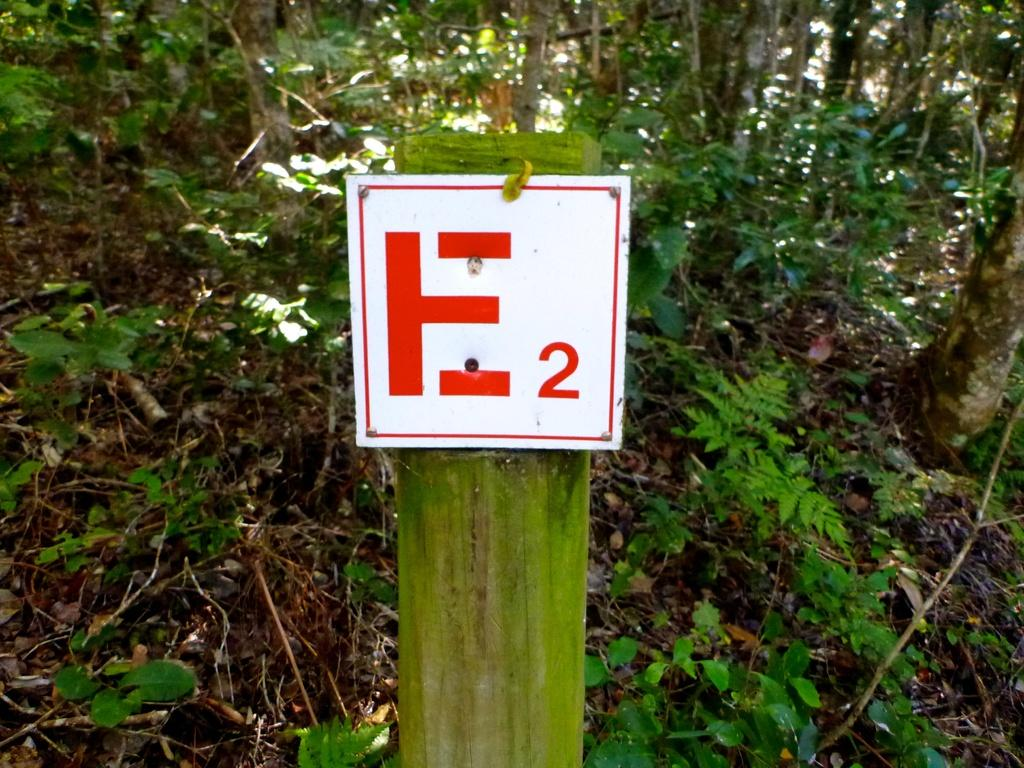What is located in the center of the image? There is a board in the center of the image. What can be seen in the background of the image? There are trees and plants in the background of the image. What type of police uniform can be seen in the image? There is no police uniform present in the image. What time of day is depicted in the image? The time of day cannot be determined from the image, as there are no specific time indicators present. 